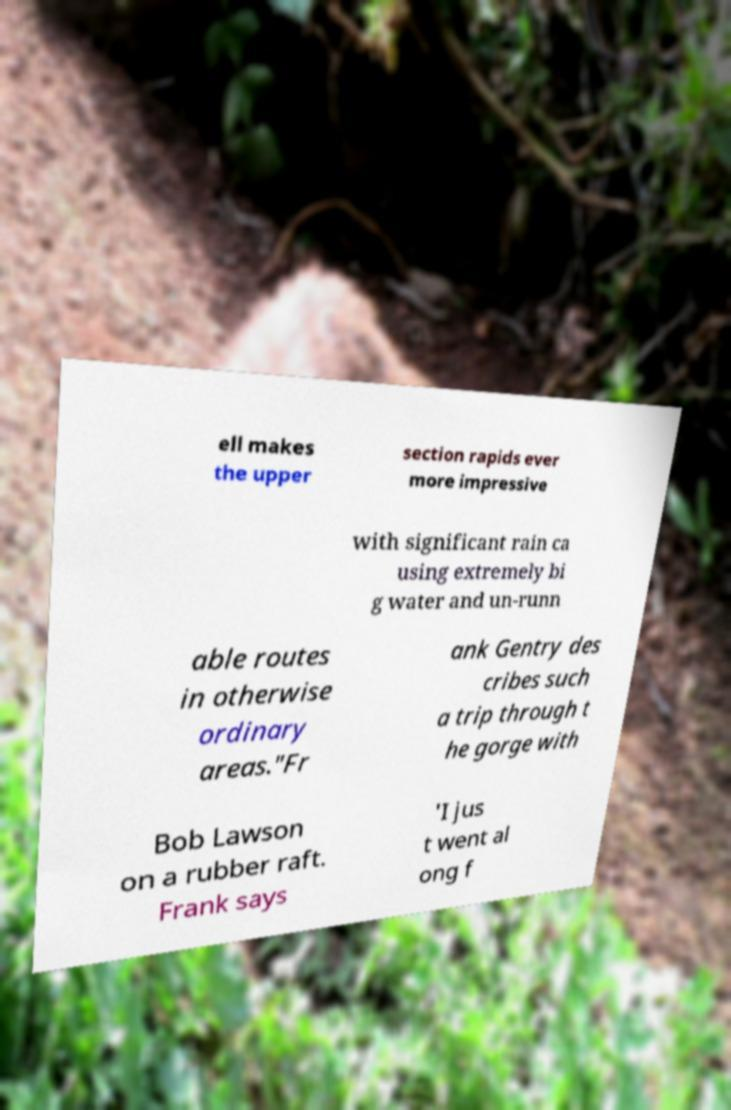Could you extract and type out the text from this image? ell makes the upper section rapids ever more impressive with significant rain ca using extremely bi g water and un-runn able routes in otherwise ordinary areas."Fr ank Gentry des cribes such a trip through t he gorge with Bob Lawson on a rubber raft. Frank says 'I jus t went al ong f 